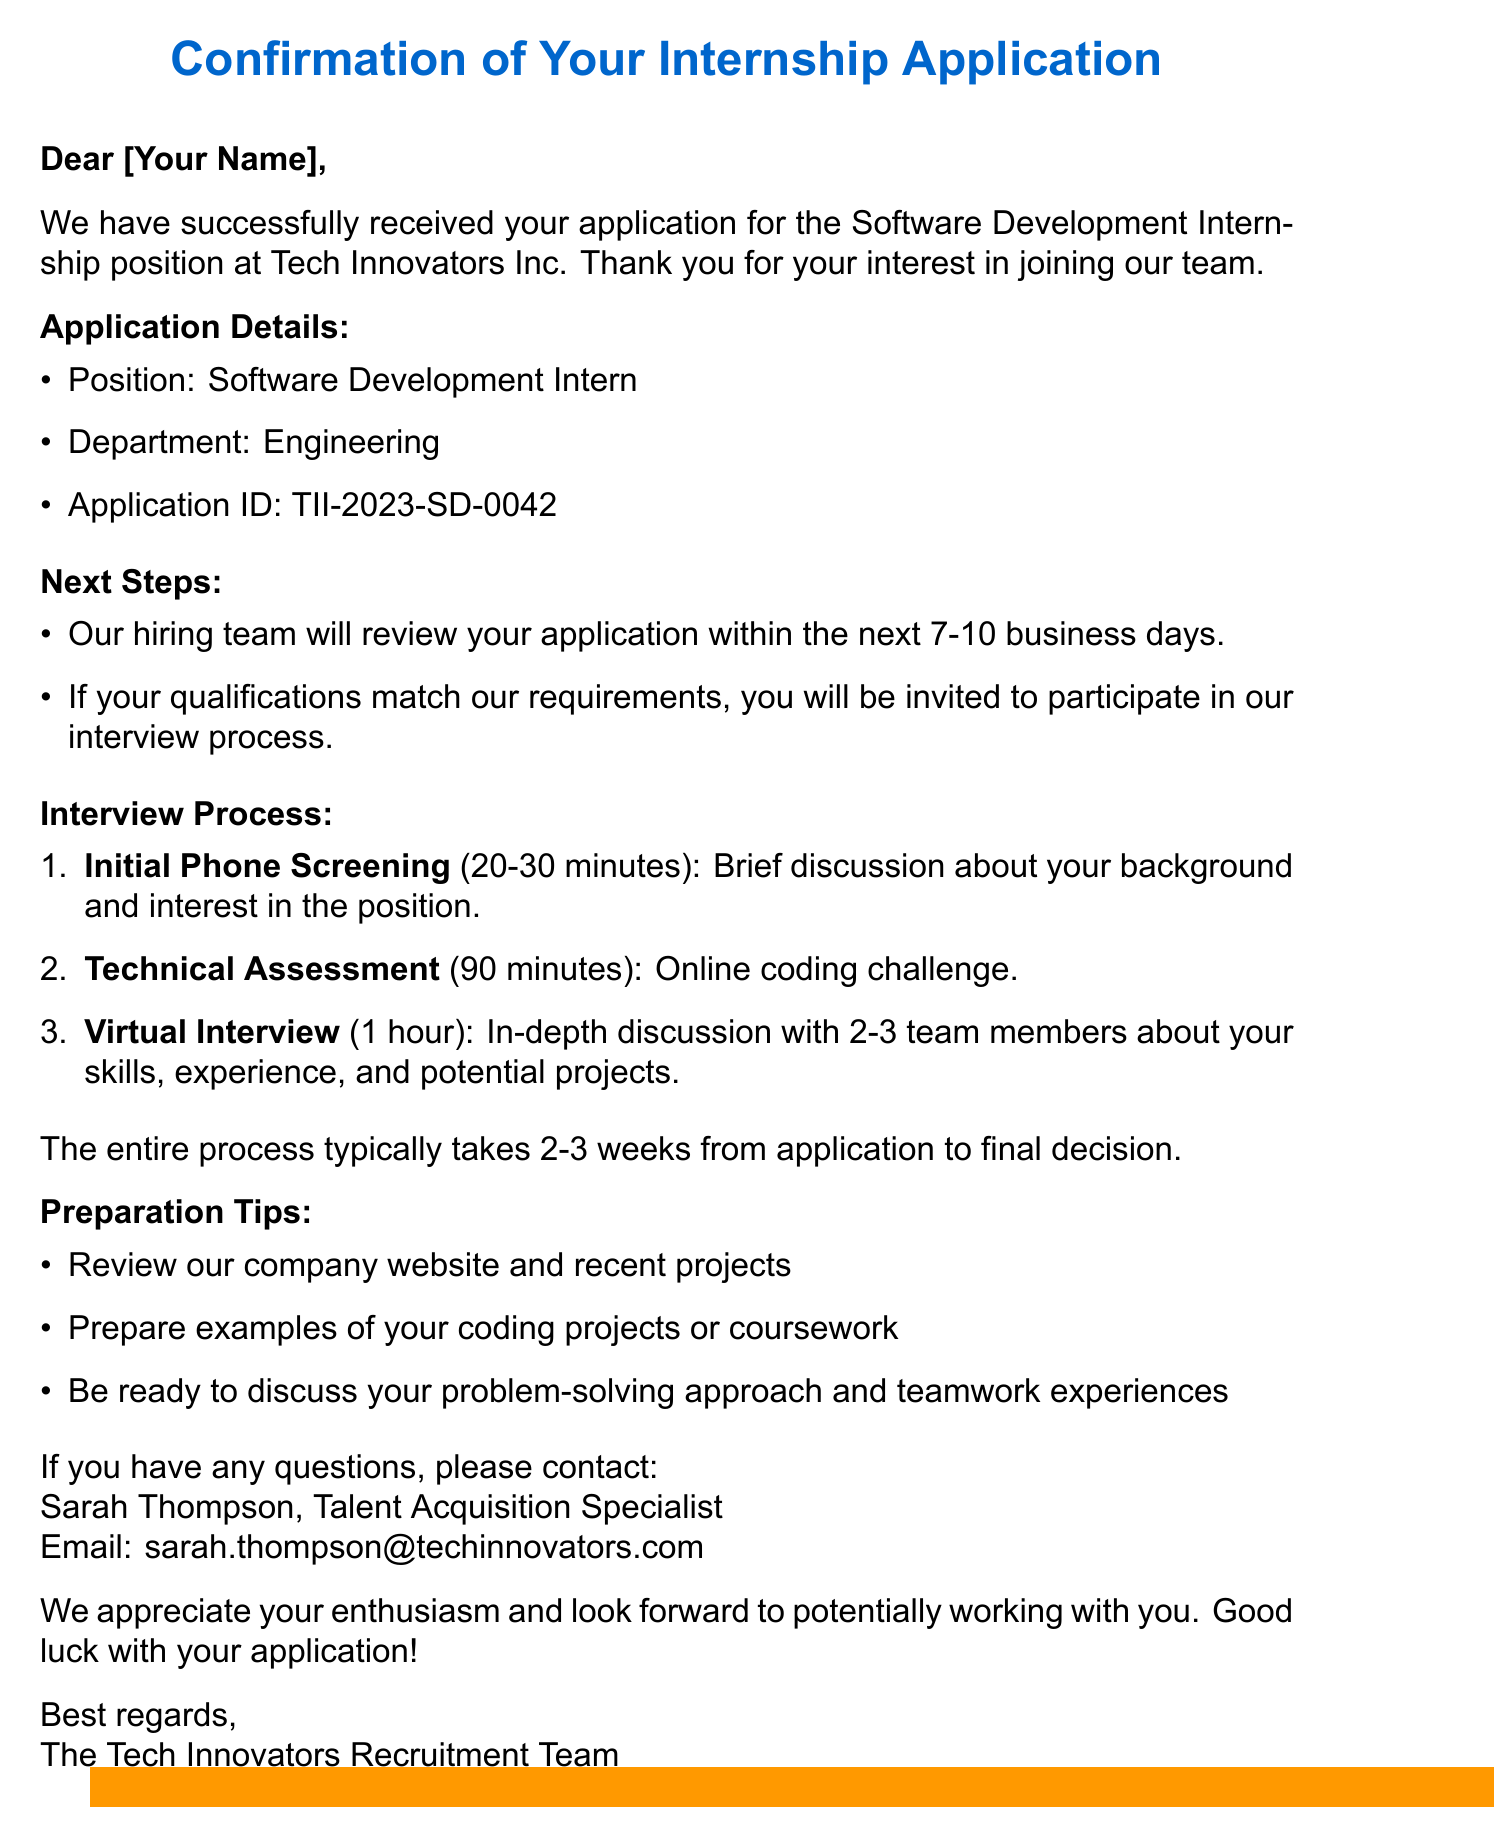What is the position applied for? The position applied for is specified under application details in the document.
Answer: Software Development Intern Who is the contact person for inquiries? The document provides the name and title of the contact person for any questions.
Answer: Sarah Thompson What is the application ID? The application ID is clearly stated in the application details section of the document.
Answer: TII-2023-SD-0042 How long will it take to review the application? The document states the expected timeline for application review.
Answer: 7-10 business days What is the duration of the Initial Phone Screening? The duration of the Initial Phone Screening is mentioned in the interview process section.
Answer: 20-30 minutes What is the total duration of the interview process? The document gives an overall timeframe for the entire selection process from application to decision.
Answer: 2-3 weeks What will be the focus of the Virtual Interview? The document outlines what will be discussed during the Virtual Interview.
Answer: In-depth discussion of your skills, experience, and potential projects What is one of the preparation tips listed? The document includes several tips for preparation, which are listed in preparation tips.
Answer: Review our company website and recent projects 